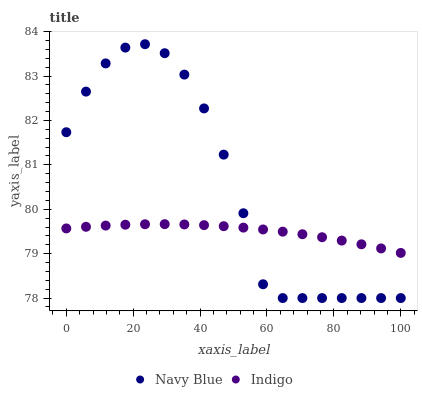Does Indigo have the minimum area under the curve?
Answer yes or no. Yes. Does Navy Blue have the maximum area under the curve?
Answer yes or no. Yes. Does Indigo have the maximum area under the curve?
Answer yes or no. No. Is Indigo the smoothest?
Answer yes or no. Yes. Is Navy Blue the roughest?
Answer yes or no. Yes. Is Indigo the roughest?
Answer yes or no. No. Does Navy Blue have the lowest value?
Answer yes or no. Yes. Does Indigo have the lowest value?
Answer yes or no. No. Does Navy Blue have the highest value?
Answer yes or no. Yes. Does Indigo have the highest value?
Answer yes or no. No. Does Navy Blue intersect Indigo?
Answer yes or no. Yes. Is Navy Blue less than Indigo?
Answer yes or no. No. Is Navy Blue greater than Indigo?
Answer yes or no. No. 